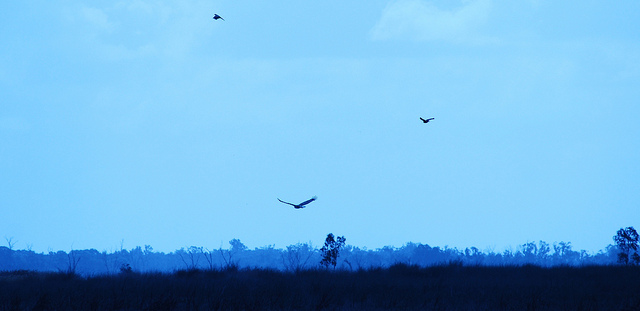<image>What time of day is it? It is unclear what time of day it is. It could be anywhere from afternoon to evening. What time of day is it? I don't know what time of day it is. It could be dusk, evening, early evening, daytime, late afternoon, sunrise, afternoon or dusk. 